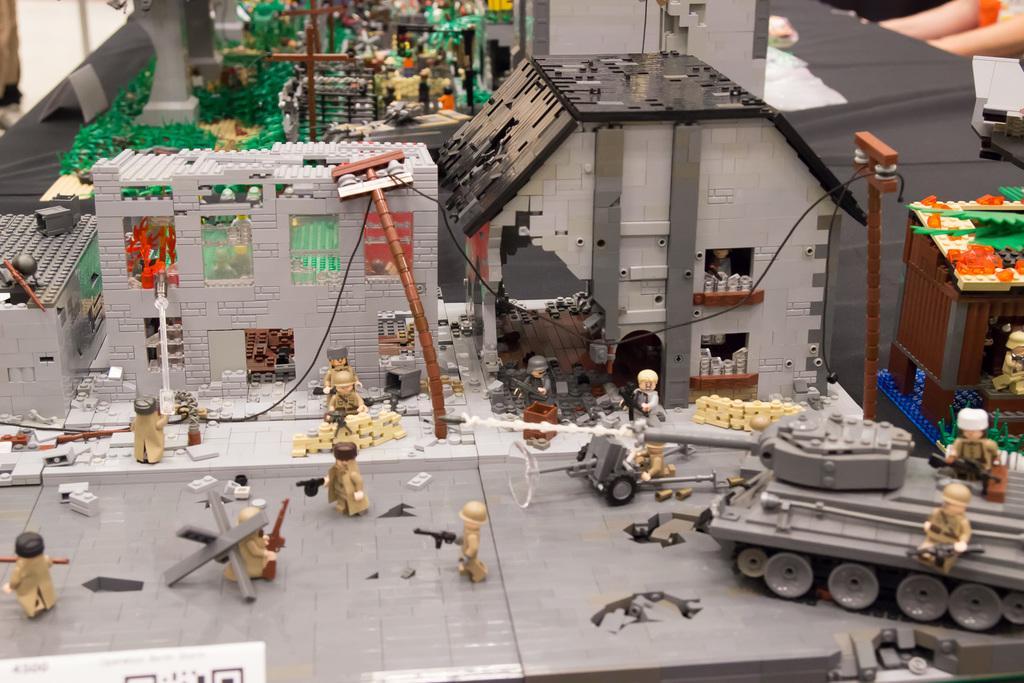Please provide a concise description of this image. This image is a depiction. In this image we can see the houses, electrical poles, wires, people, weapons, path, war tank and also some playing objects. 